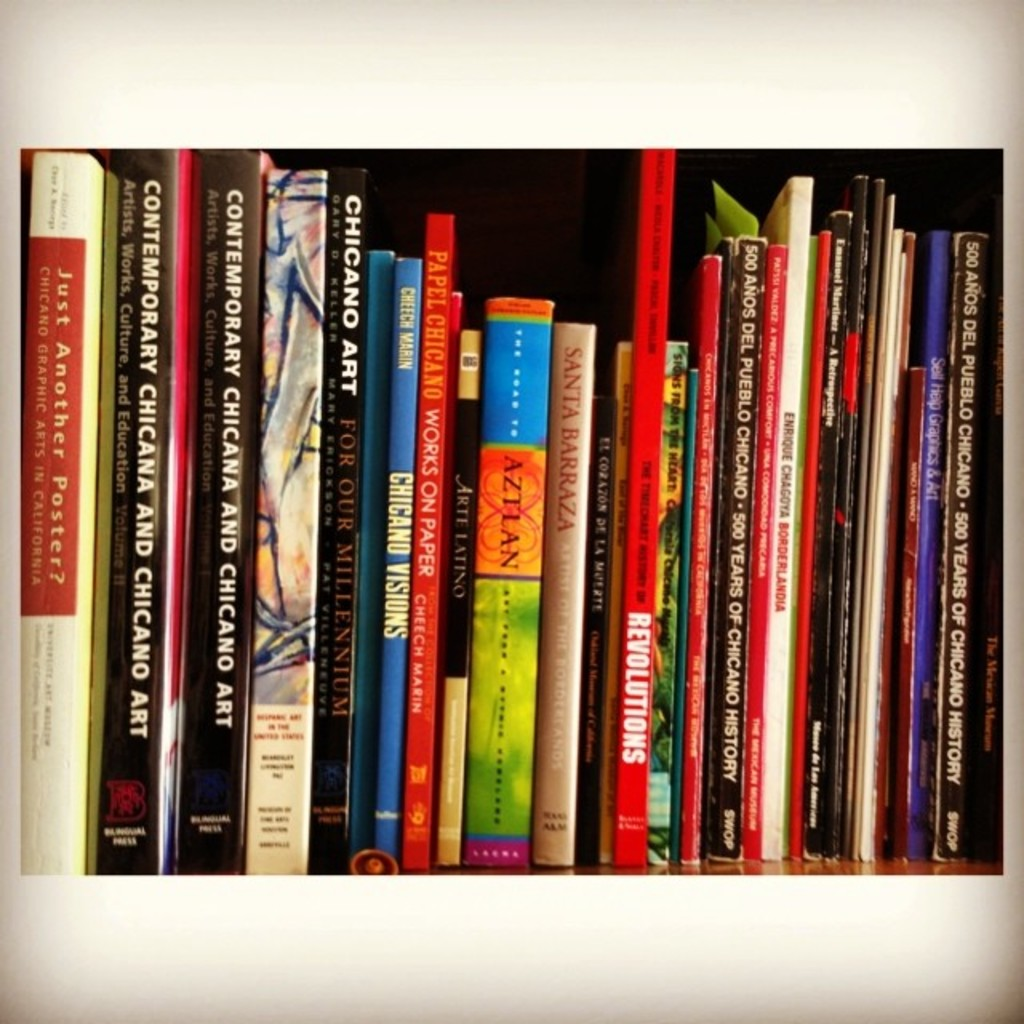Provide a one-sentence caption for the provided image.
Reference OCR token: 5, NYHOdWEINO, AUVBOdW3INO, ONVOIHO, WH333H3, UELELSH, 18v, 20, VNVJIHD, VNVJIHD, ..**, YOa, SX8OM, aNY, CNV, ano, ONW3IH3, 83dVdNO, ONVJIHD, ONVJIHD, SNOISI, AE, WOINNE, ULS, " A row of colorful books many of them having Chicago and Art in their titles. 